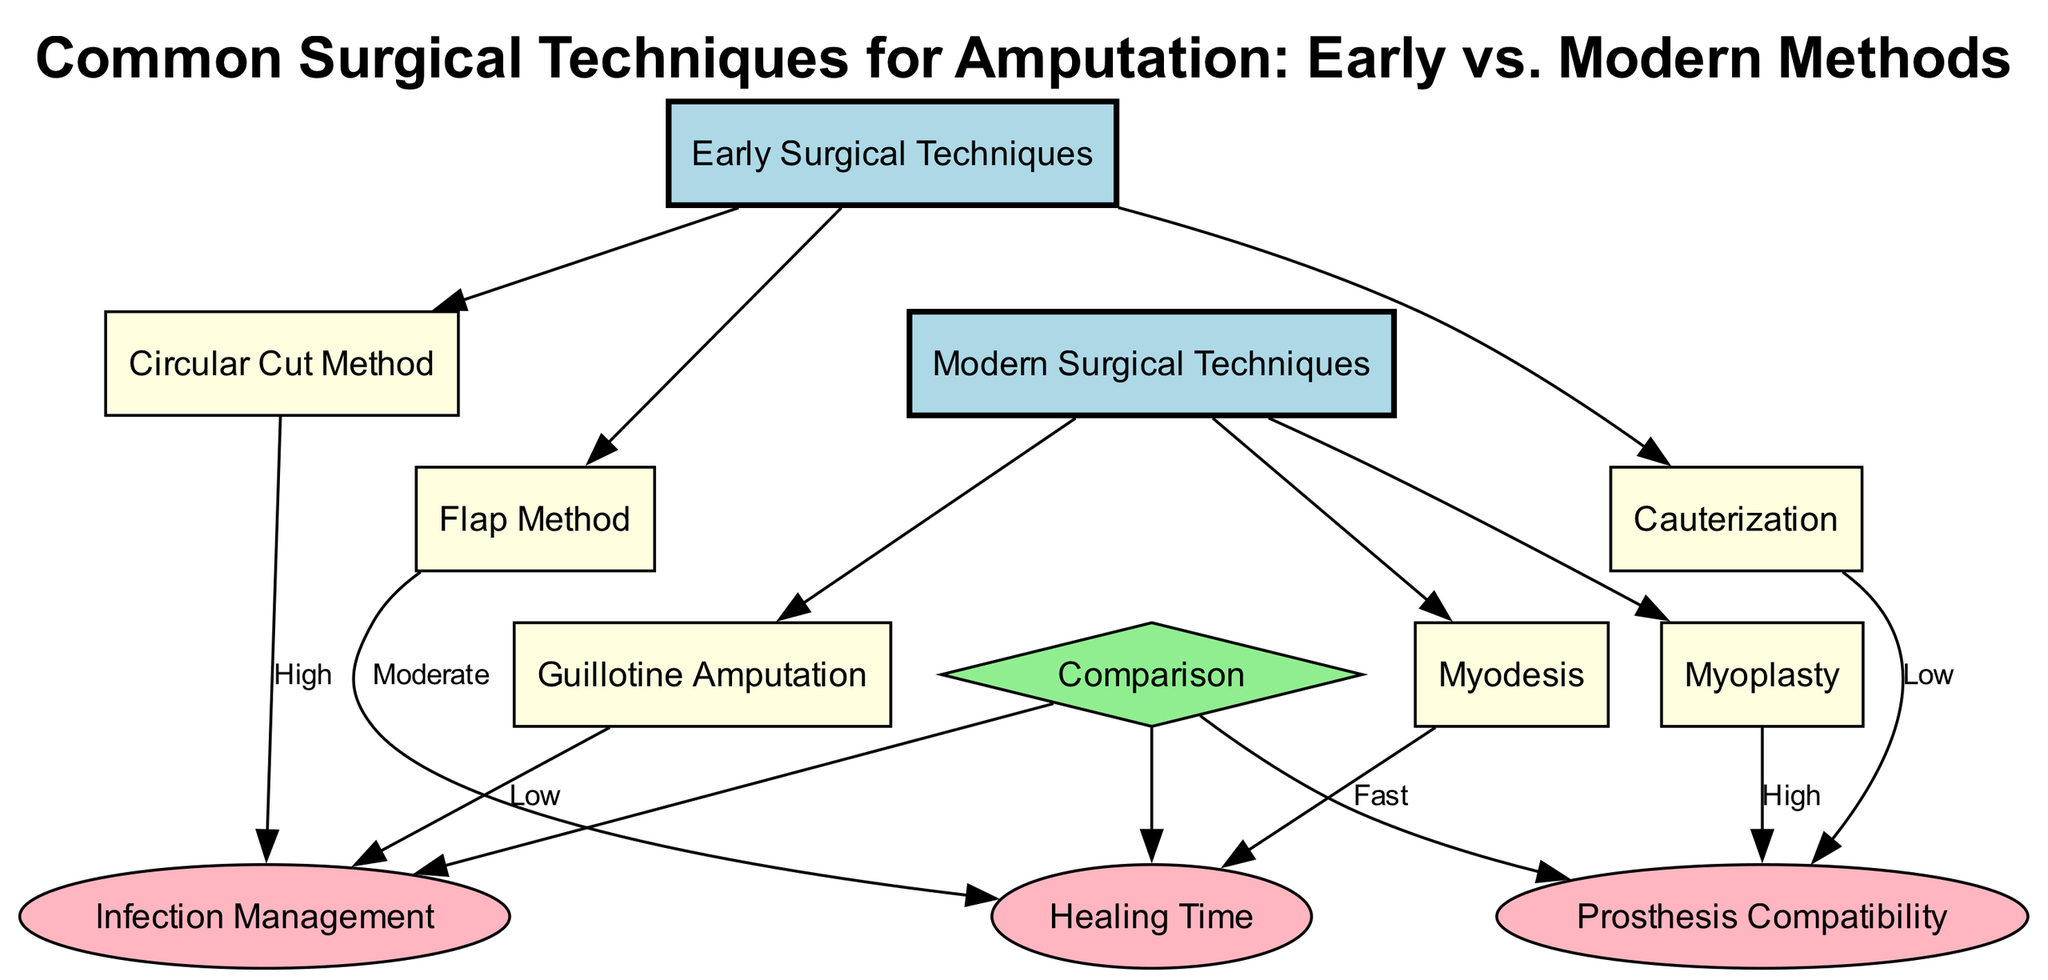What are the three early surgical techniques? The diagram lists three early surgical techniques under the "Early Surgical Techniques" category: Circular Cut Method, Flap Method, and Cauterization.
Answer: Circular Cut Method, Flap Method, Cauterization Which modern surgical technique is focused on muscle attachment? The modern surgical technique that focuses on muscle attachment is Myodesis, which is mentioned under the "Modern Surgical Techniques" category.
Answer: Myodesis What is the comparison metric associated with the Circular Cut Method? The Circular Cut Method is linked to the Infection Management comparison metric, and the diagram indicates a "High" label for this relationship.
Answer: High How many types of modern surgical techniques are shown in the diagram? The diagram shows three modern surgical techniques: Guillotine Amputation, Myodesis, and Myoplasty. Counting these gives a total of three techniques.
Answer: 3 Which early technique has a "Low" rating for Prosthesis Compatibility? Cauterization is associated with a "Low" rating for Prosthesis Compatibility in the diagram as identified in the comparison section.
Answer: Cauterization What metric has the "Fast" attribute in the modern techniques? Myodesis is linked to the Healing Time metric with a "Fast" attribute, showing that this technique allows for quicker healing compared to others.
Answer: Fast Which early surgical technique is associated with High infection management? The Circular Cut Method is linked to the Infection Management metric with a "High" designation, indicating a significant concern with this method.
Answer: Circular Cut Method What are the three comparison metrics presented in the diagram? The diagram presents three comparison metrics: Infection Management, Healing Time, and Prosthesis Compatibility under the Comparison category.
Answer: Infection Management, Healing Time, Prosthesis Compatibility What is the label associated with Myoplasty concerning Prosthesis Compatibility? Myoplasty is associated with a "High" label for Prosthesis Compatibility, indicating that this technique allows for better integration with prosthetics.
Answer: High 